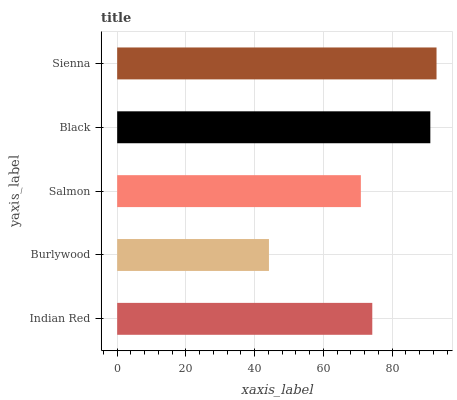Is Burlywood the minimum?
Answer yes or no. Yes. Is Sienna the maximum?
Answer yes or no. Yes. Is Salmon the minimum?
Answer yes or no. No. Is Salmon the maximum?
Answer yes or no. No. Is Salmon greater than Burlywood?
Answer yes or no. Yes. Is Burlywood less than Salmon?
Answer yes or no. Yes. Is Burlywood greater than Salmon?
Answer yes or no. No. Is Salmon less than Burlywood?
Answer yes or no. No. Is Indian Red the high median?
Answer yes or no. Yes. Is Indian Red the low median?
Answer yes or no. Yes. Is Sienna the high median?
Answer yes or no. No. Is Burlywood the low median?
Answer yes or no. No. 